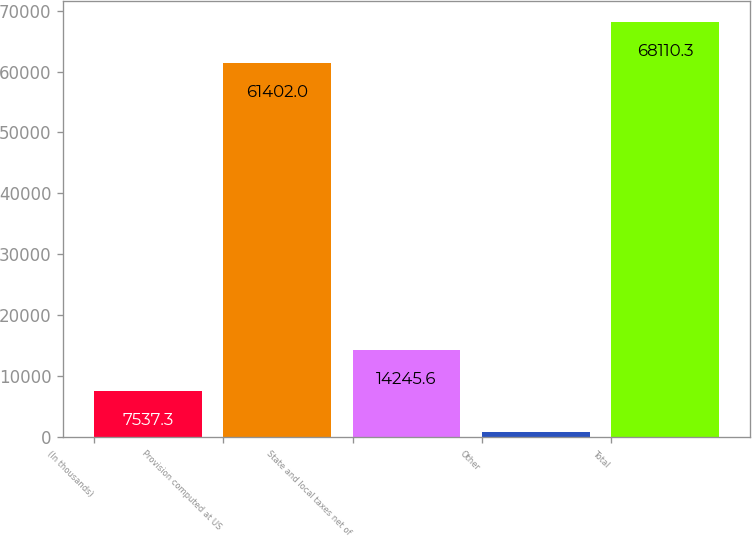Convert chart to OTSL. <chart><loc_0><loc_0><loc_500><loc_500><bar_chart><fcel>(In thousands)<fcel>Provision computed at US<fcel>State and local taxes net of<fcel>Other<fcel>Total<nl><fcel>7537.3<fcel>61402<fcel>14245.6<fcel>829<fcel>68110.3<nl></chart> 